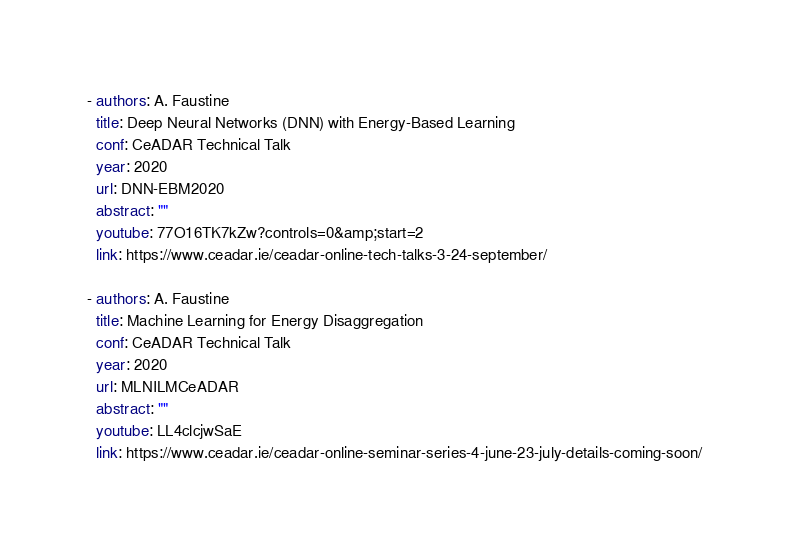Convert code to text. <code><loc_0><loc_0><loc_500><loc_500><_YAML_>- authors: A. Faustine
  title: Deep Neural Networks (DNN) with Energy-Based Learning
  conf: CeADAR Technical Talk
  year: 2020
  url: DNN-EBM2020
  abstract: ""
  youtube: 77O16TK7kZw?controls=0&amp;start=2
  link: https://www.ceadar.ie/ceadar-online-tech-talks-3-24-september/

- authors: A. Faustine
  title: Machine Learning for Energy Disaggregation
  conf: CeADAR Technical Talk
  year: 2020
  url: MLNILMCeADAR
  abstract: ""
  youtube: LL4clcjwSaE
  link: https://www.ceadar.ie/ceadar-online-seminar-series-4-june-23-july-details-coming-soon/

</code> 